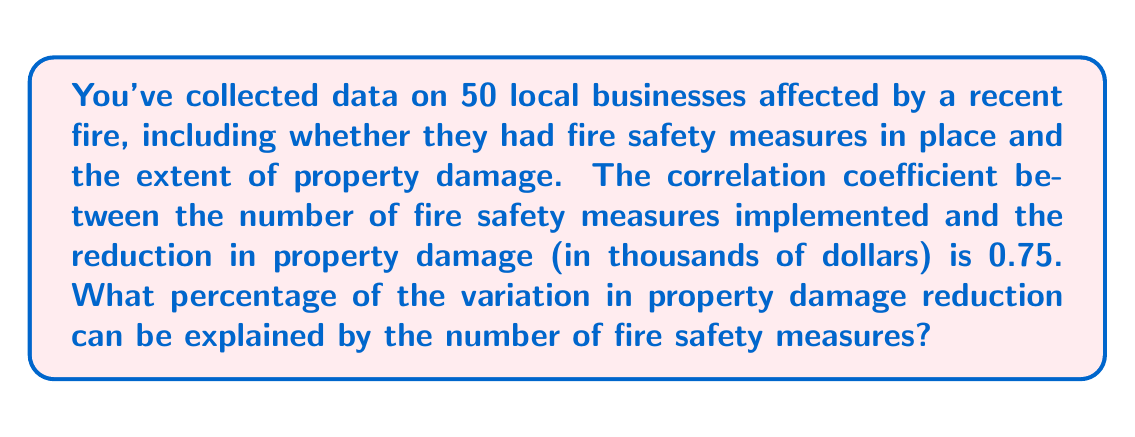Show me your answer to this math problem. To solve this problem, we need to understand the concept of the coefficient of determination, also known as R-squared.

1. The correlation coefficient (r) is given as 0.75.

2. The coefficient of determination (R-squared) is the square of the correlation coefficient:

   $$R^2 = r^2$$

3. Calculate R-squared:
   $$R^2 = (0.75)^2 = 0.5625$$

4. Convert to a percentage:
   $$0.5625 \times 100\% = 56.25\%$$

5. Interpretation: 56.25% of the variation in property damage reduction can be explained by the number of fire safety measures implemented.

This means that there's a moderately strong relationship between fire safety measures and reduced property damage. As a local business owner, this information suggests that investing in fire safety measures could significantly reduce potential property damage in case of a fire.
Answer: 56.25% 